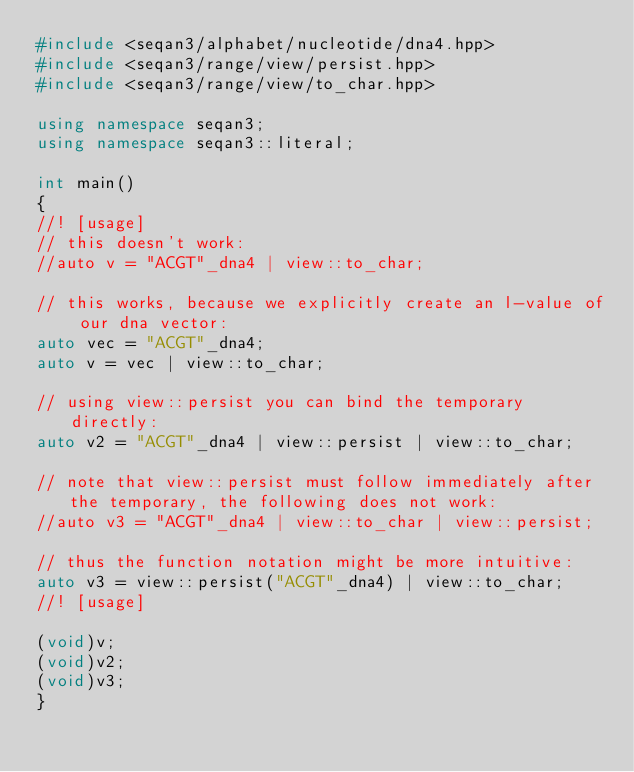Convert code to text. <code><loc_0><loc_0><loc_500><loc_500><_C++_>#include <seqan3/alphabet/nucleotide/dna4.hpp>
#include <seqan3/range/view/persist.hpp>
#include <seqan3/range/view/to_char.hpp>

using namespace seqan3;
using namespace seqan3::literal;

int main()
{
//! [usage]
// this doesn't work:
//auto v = "ACGT"_dna4 | view::to_char;

// this works, because we explicitly create an l-value of our dna vector:
auto vec = "ACGT"_dna4;
auto v = vec | view::to_char;

// using view::persist you can bind the temporary directly:
auto v2 = "ACGT"_dna4 | view::persist | view::to_char;

// note that view::persist must follow immediately after the temporary, the following does not work:
//auto v3 = "ACGT"_dna4 | view::to_char | view::persist;

// thus the function notation might be more intuitive:
auto v3 = view::persist("ACGT"_dna4) | view::to_char;
//! [usage]

(void)v;
(void)v2;
(void)v3;
}
</code> 